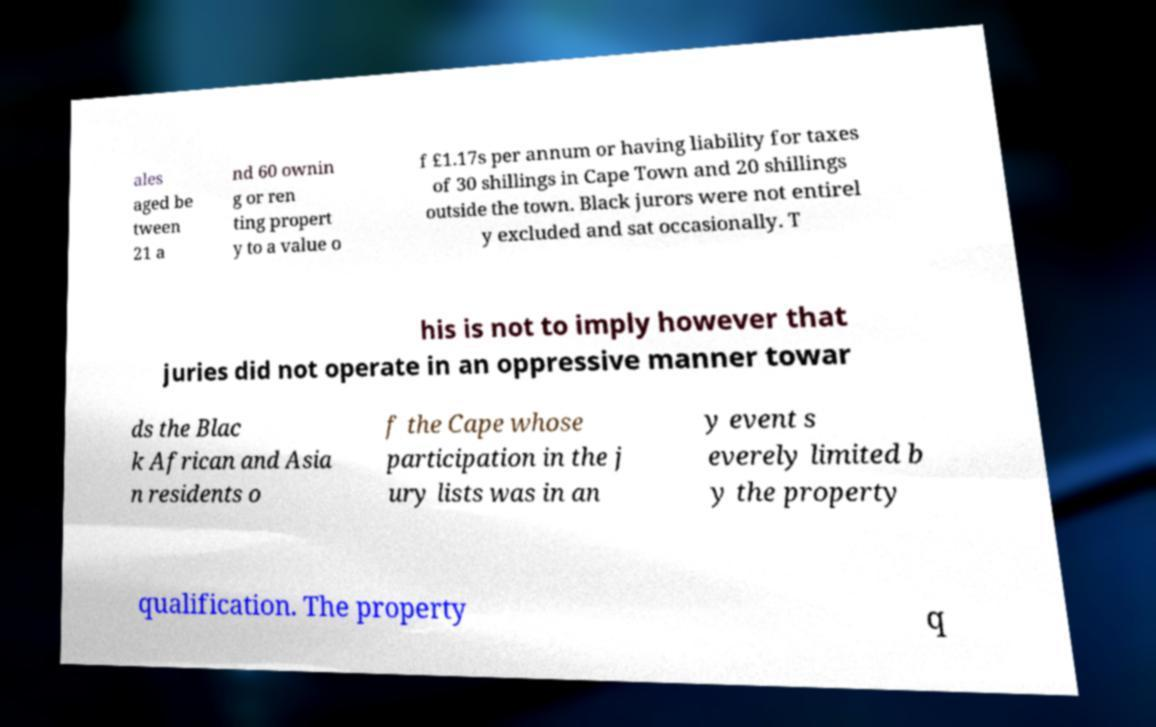Could you extract and type out the text from this image? ales aged be tween 21 a nd 60 ownin g or ren ting propert y to a value o f £1.17s per annum or having liability for taxes of 30 shillings in Cape Town and 20 shillings outside the town. Black jurors were not entirel y excluded and sat occasionally. T his is not to imply however that juries did not operate in an oppressive manner towar ds the Blac k African and Asia n residents o f the Cape whose participation in the j ury lists was in an y event s everely limited b y the property qualification. The property q 